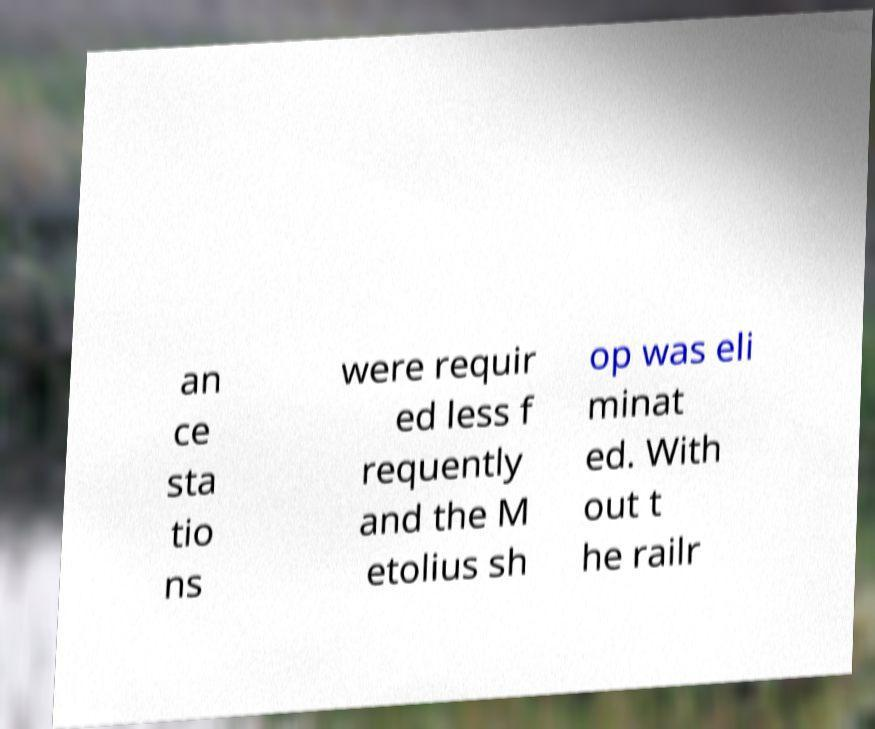What messages or text are displayed in this image? I need them in a readable, typed format. an ce sta tio ns were requir ed less f requently and the M etolius sh op was eli minat ed. With out t he railr 